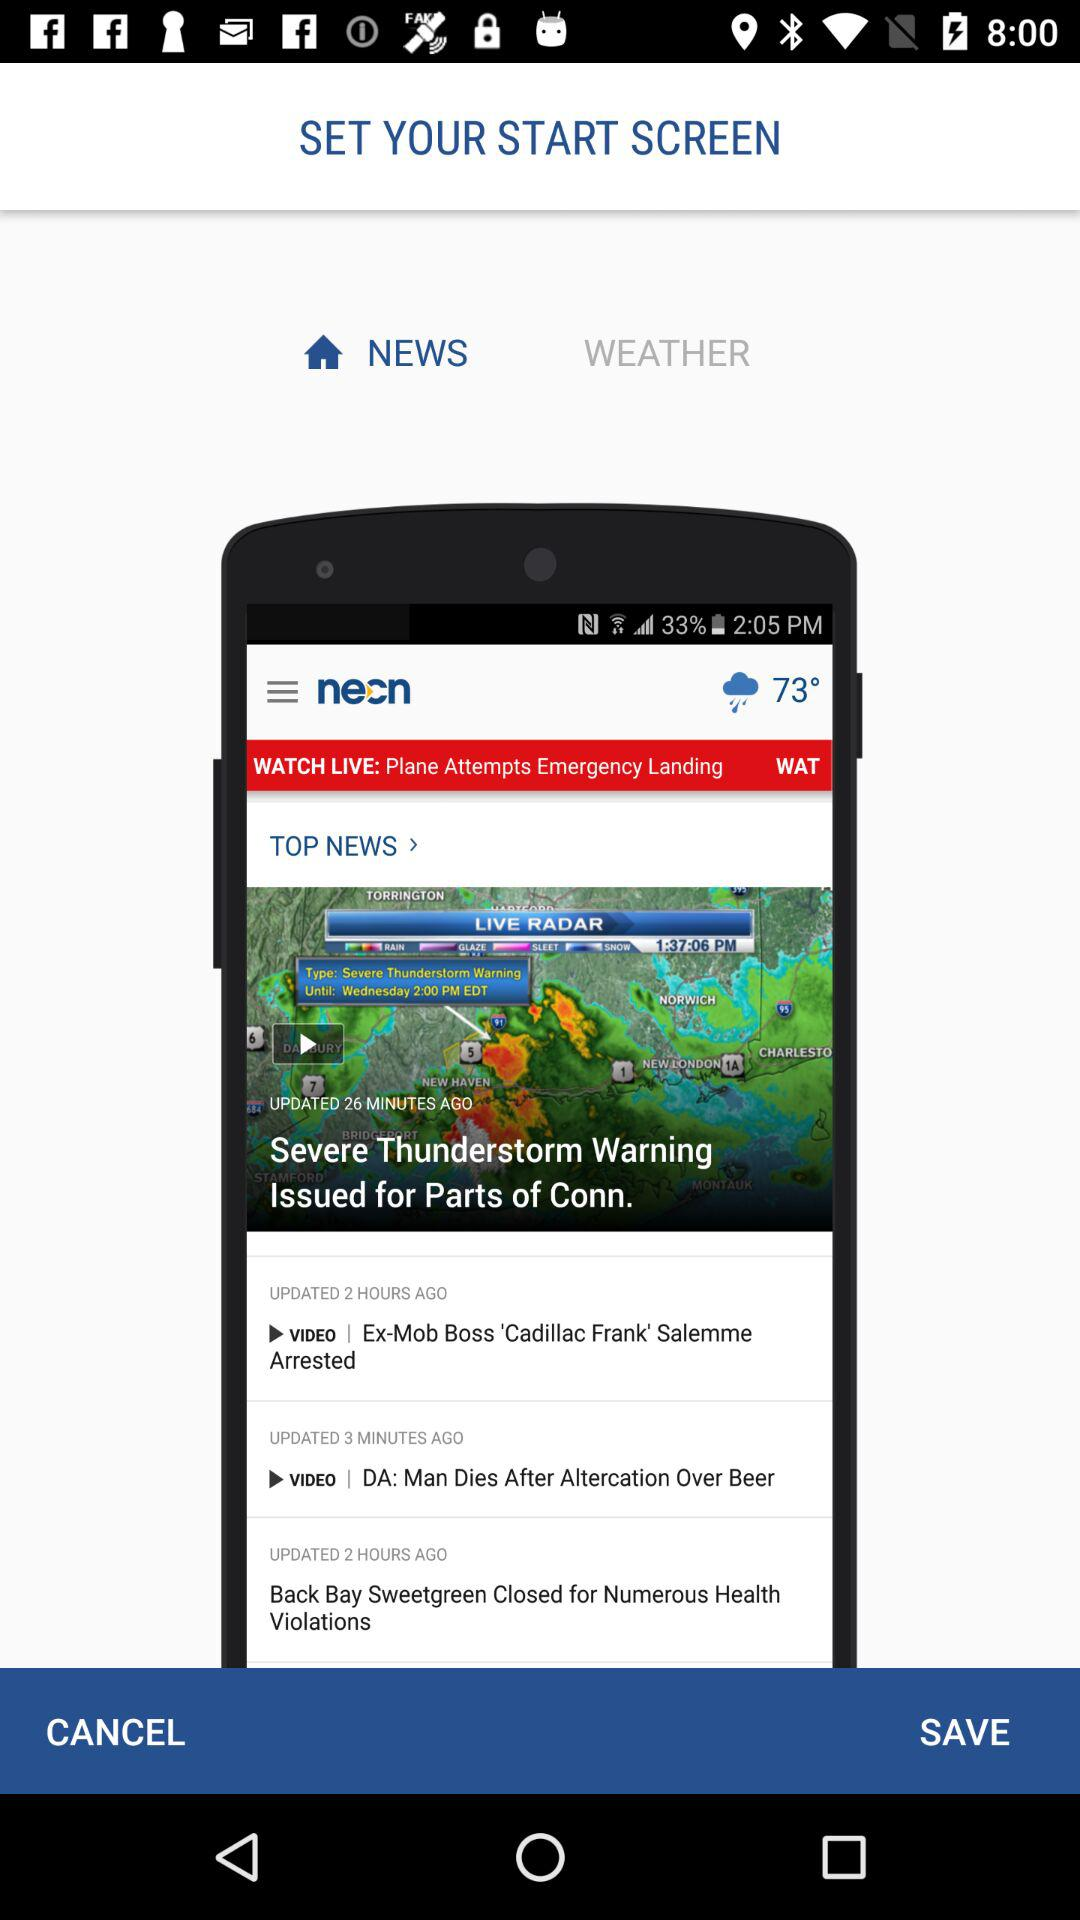What is the selected start screen? The selected start screen is "NEWS". 